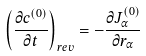Convert formula to latex. <formula><loc_0><loc_0><loc_500><loc_500>\left ( \frac { \partial c ^ { ( 0 ) } } { \partial t } \right ) _ { r e v } = - \frac { \partial J ^ { ( 0 ) } _ { \alpha } } { \partial r _ { \alpha } }</formula> 